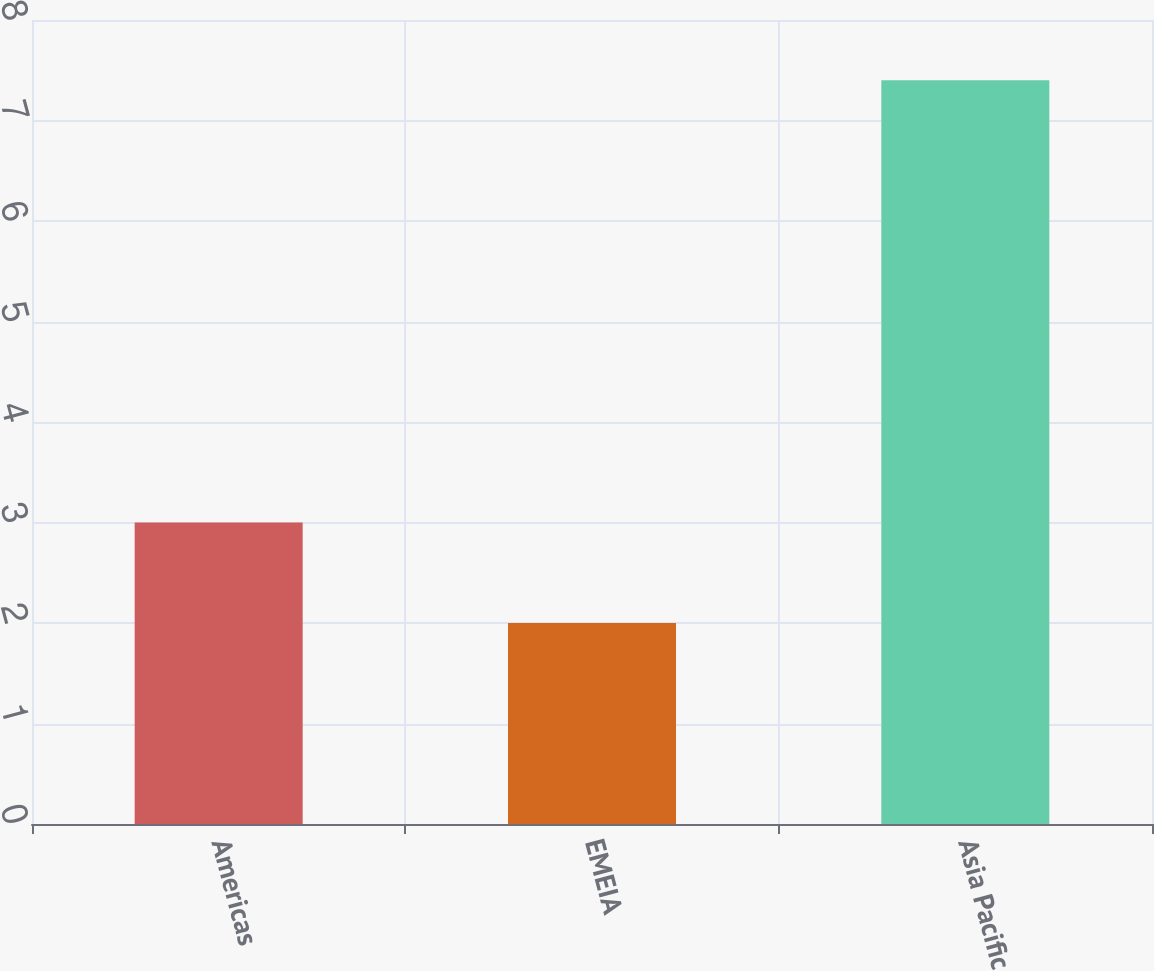Convert chart. <chart><loc_0><loc_0><loc_500><loc_500><bar_chart><fcel>Americas<fcel>EMEIA<fcel>Asia Pacific<nl><fcel>3<fcel>2<fcel>7.4<nl></chart> 